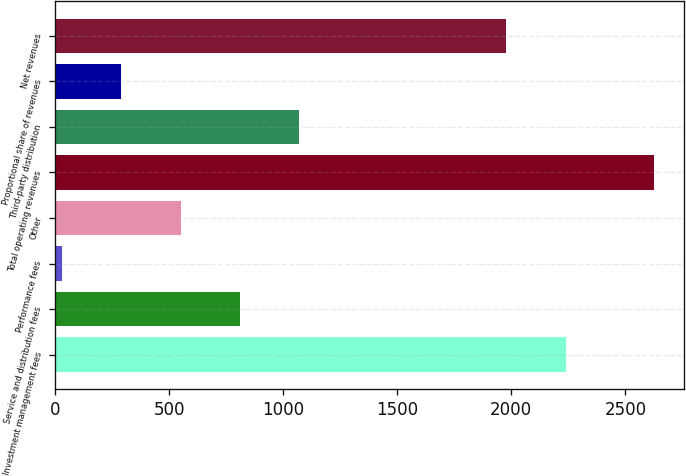Convert chart to OTSL. <chart><loc_0><loc_0><loc_500><loc_500><bar_chart><fcel>Investment management fees<fcel>Service and distribution fees<fcel>Performance fees<fcel>Other<fcel>Total operating revenues<fcel>Third-party distribution<fcel>Proportional share of revenues<fcel>Net revenues<nl><fcel>2238.43<fcel>809.19<fcel>30<fcel>549.46<fcel>2627.3<fcel>1068.92<fcel>289.73<fcel>1978.7<nl></chart> 